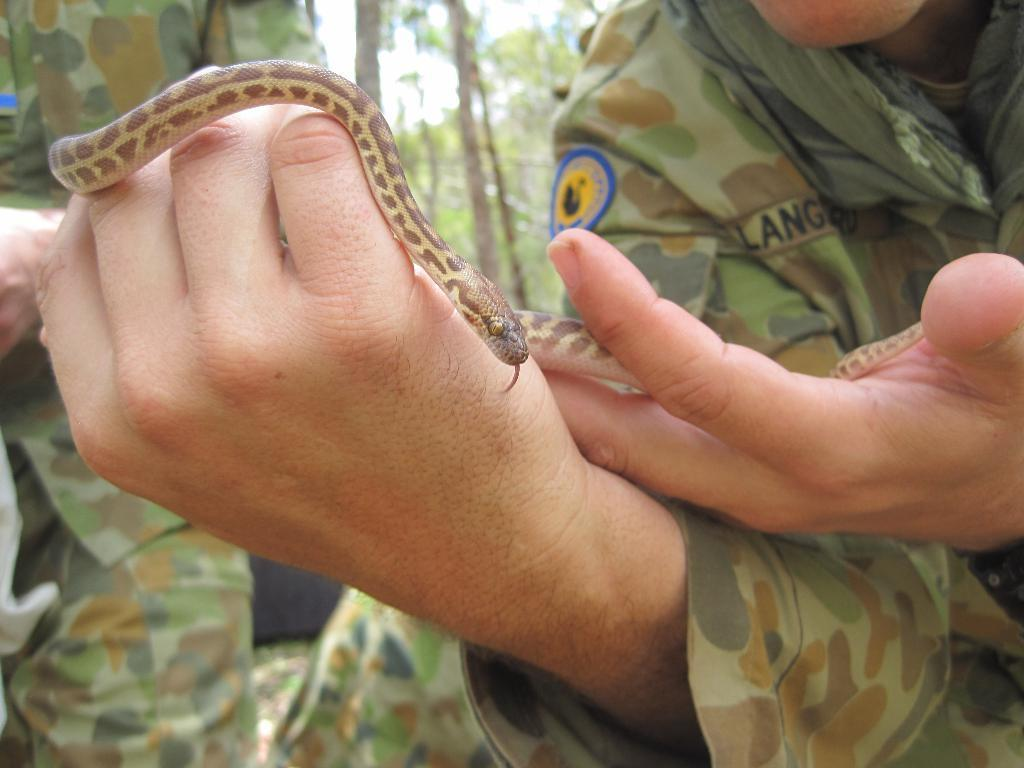What is the main subject of the image? There is a person in the image. What is the person doing in the image? The person is holding a snake in his hands. What can be seen in the background of the image? There are trees and the sky visible in the background of the image. How many icicles can be seen hanging from the person's jeans in the image? There are no icicles present in the image, nor are there any jeans mentioned. 